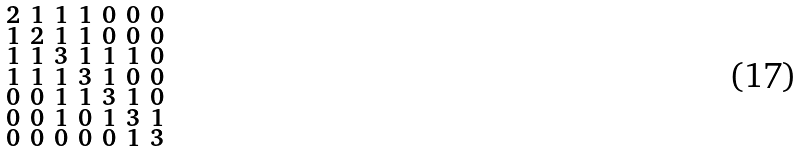Convert formula to latex. <formula><loc_0><loc_0><loc_500><loc_500>\begin{smallmatrix} 2 & 1 & 1 & 1 & 0 & 0 & 0 \\ 1 & 2 & 1 & 1 & 0 & 0 & 0 \\ 1 & 1 & 3 & 1 & 1 & 1 & 0 \\ 1 & 1 & 1 & 3 & 1 & 0 & 0 \\ 0 & 0 & 1 & 1 & 3 & 1 & 0 \\ 0 & 0 & 1 & 0 & 1 & 3 & 1 \\ 0 & 0 & 0 & 0 & 0 & 1 & 3 \end{smallmatrix}</formula> 